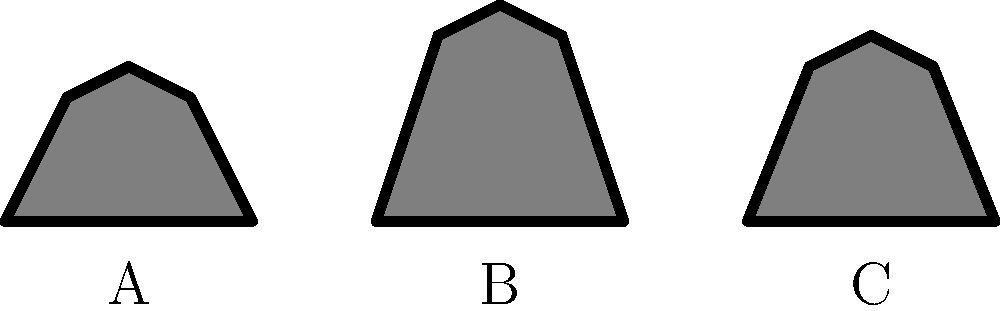Identify the silhouette of Petra Kvitová, the two-time Wimbledon champion, from the given options A, B, and C. To identify Petra Kvitová's silhouette, let's analyze each option:

1. Silhouette A: This figure has a distinctive rounded top, which is characteristic of Petra Kvitová's hairstyle. She often wears her hair in a ponytail during matches, creating this rounded shape.

2. Silhouette B: This figure has a more angular top, suggesting a different hairstyle or possibly a male player with shorter hair.

3. Silhouette C: This silhouette also appears to have a more angular top, similar to silhouette B.

Petra Kvitová is known for her left-handed play and powerful groundstrokes. While we can't see these details in the silhouette, the distinctive hair shape in silhouette A matches her typical appearance on court.

Given Petra's status as a two-time Wimbledon champion and one of the most successful Czech tennis players in recent years, it's crucial for a Czech tennis fan to recognize her silhouette.

Therefore, the silhouette of Petra Kvitová is most likely represented by option A.
Answer: A 